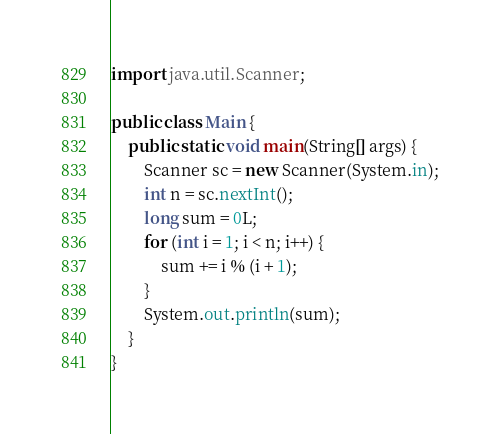<code> <loc_0><loc_0><loc_500><loc_500><_Java_>import java.util.Scanner;

public class Main {
	public static void main(String[] args) {
		Scanner sc = new Scanner(System.in);
		int n = sc.nextInt();
		long sum = 0L;
		for (int i = 1; i < n; i++) {
			sum += i % (i + 1);
		}
		System.out.println(sum);
	}
}
</code> 